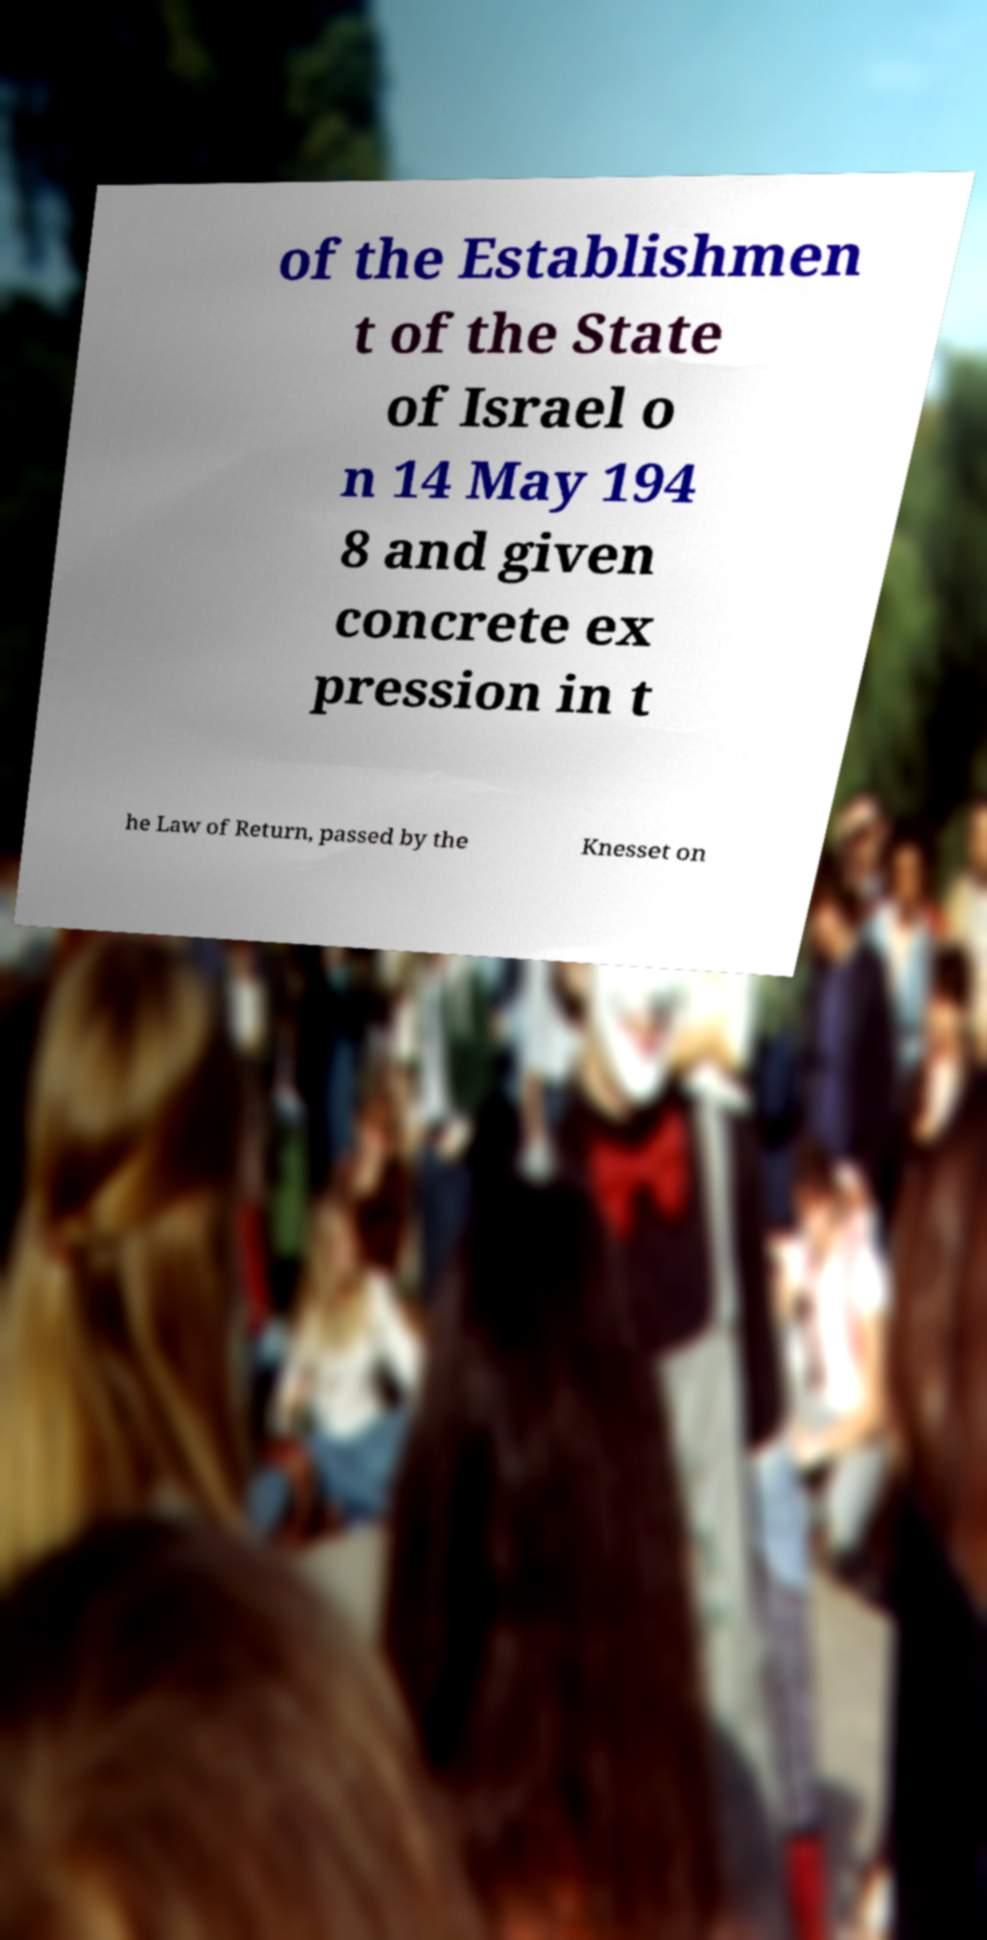Could you extract and type out the text from this image? of the Establishmen t of the State of Israel o n 14 May 194 8 and given concrete ex pression in t he Law of Return, passed by the Knesset on 